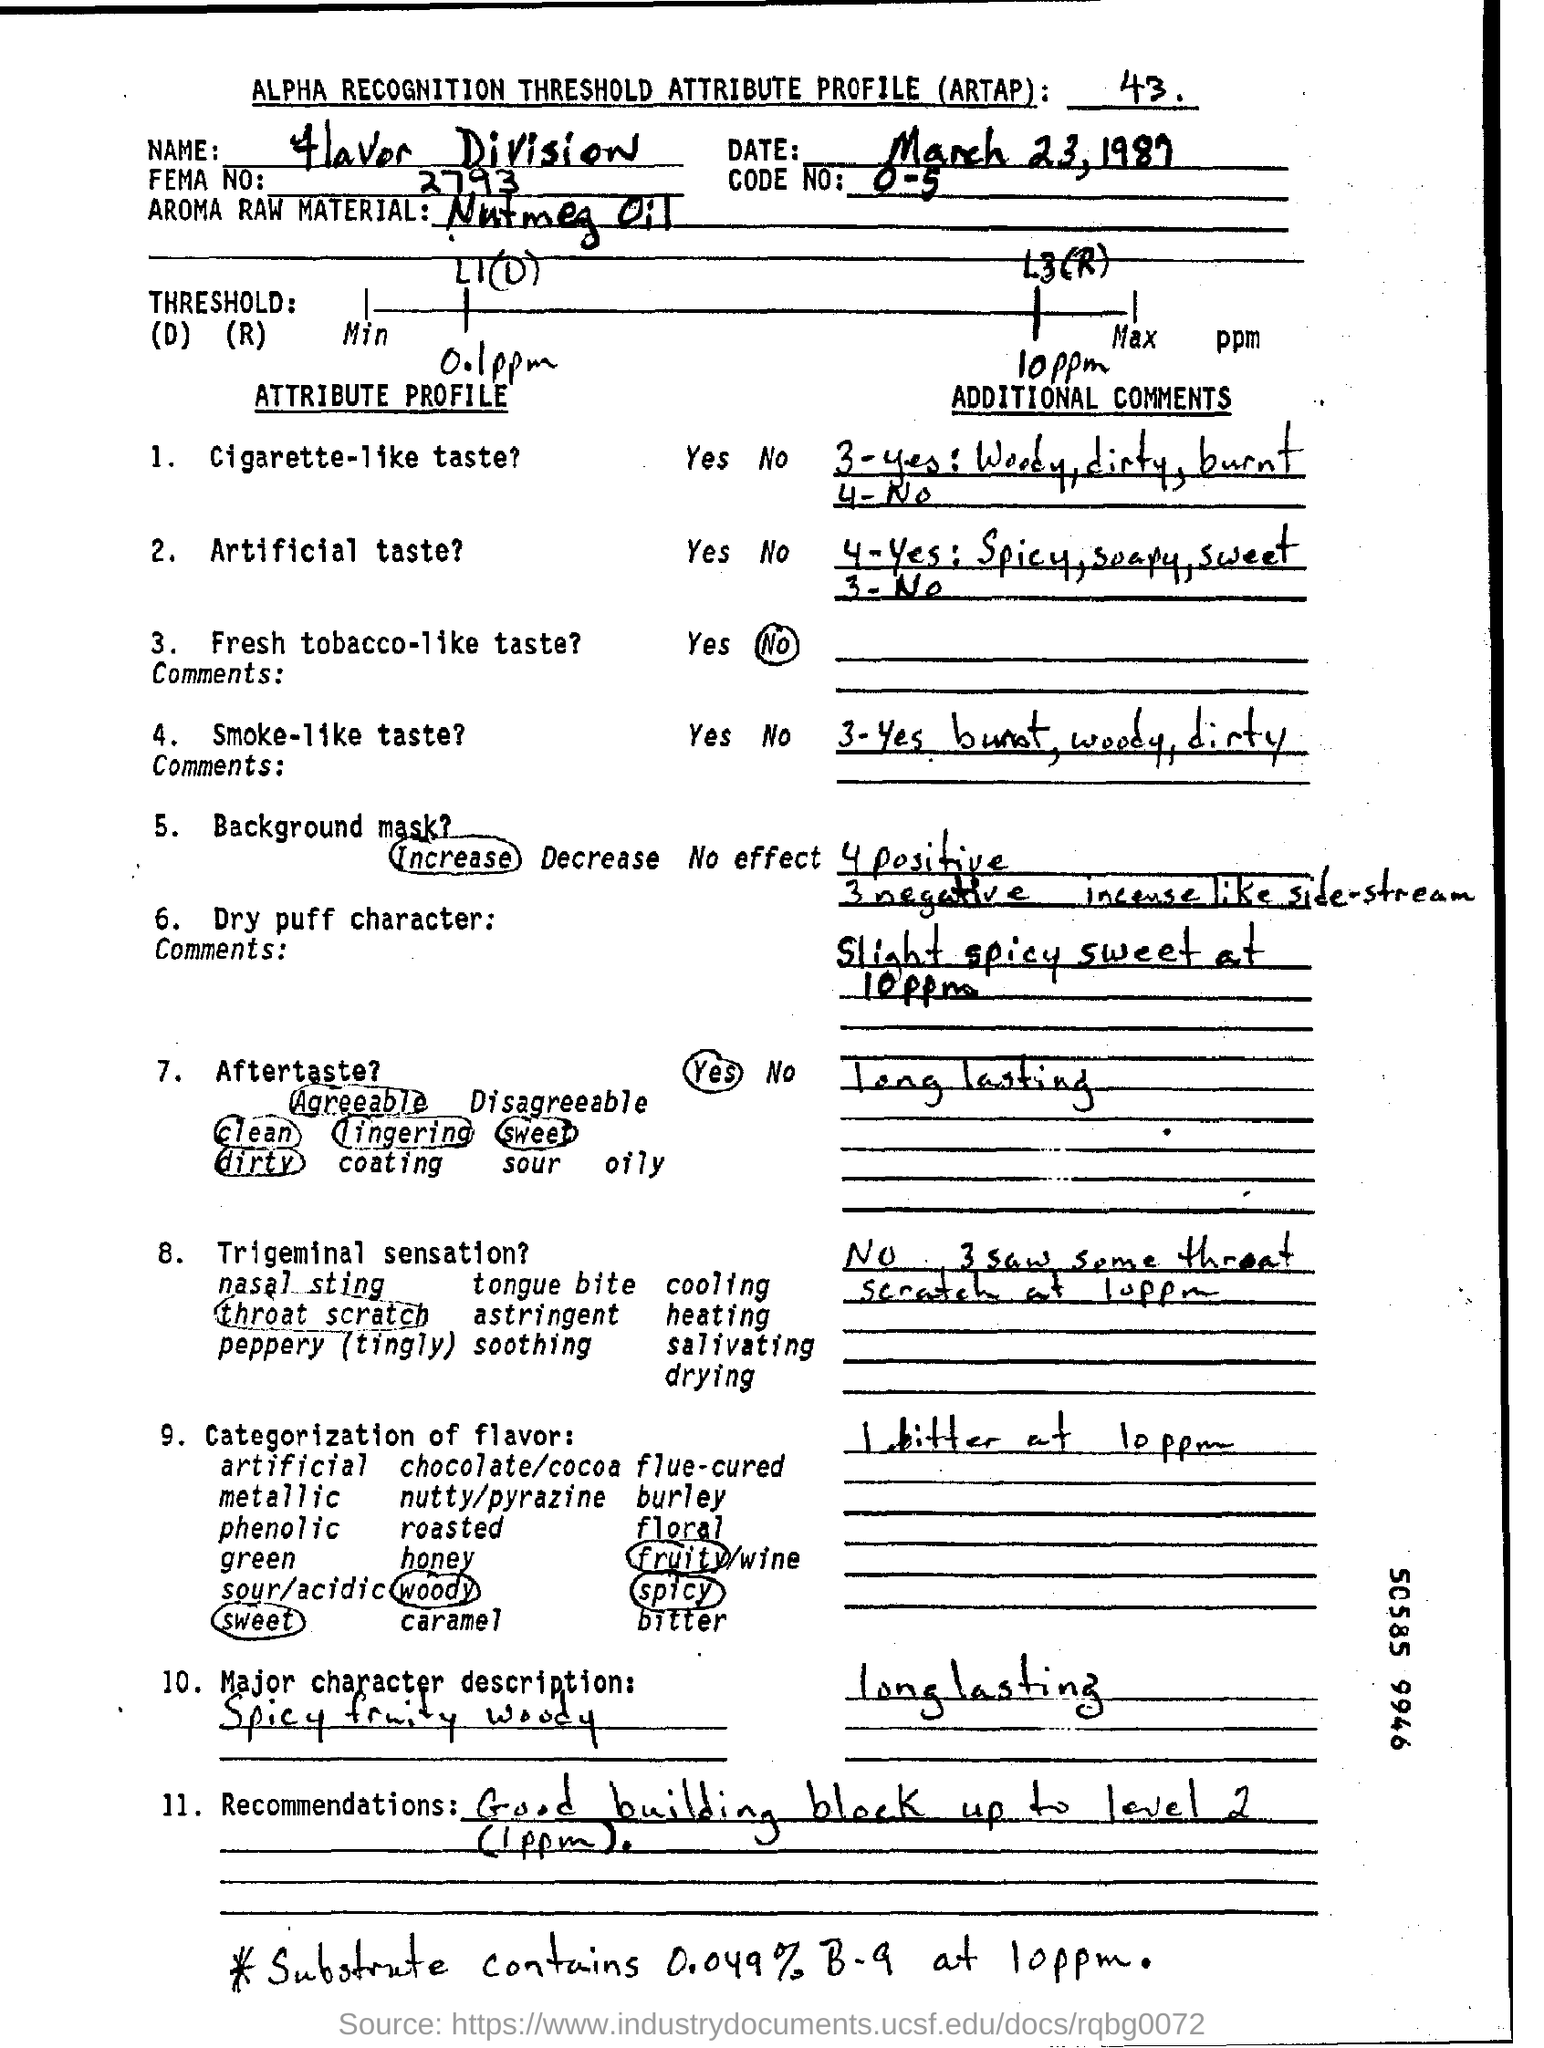Indicate a few pertinent items in this graphic. The FEMA number is 2793, according to the information provided. The name written in the name field is Flavor Division. The code number is a numerical value ranging from 0 to 5, inclusive. The date mentioned at the beginning of the document is March 23rd. 